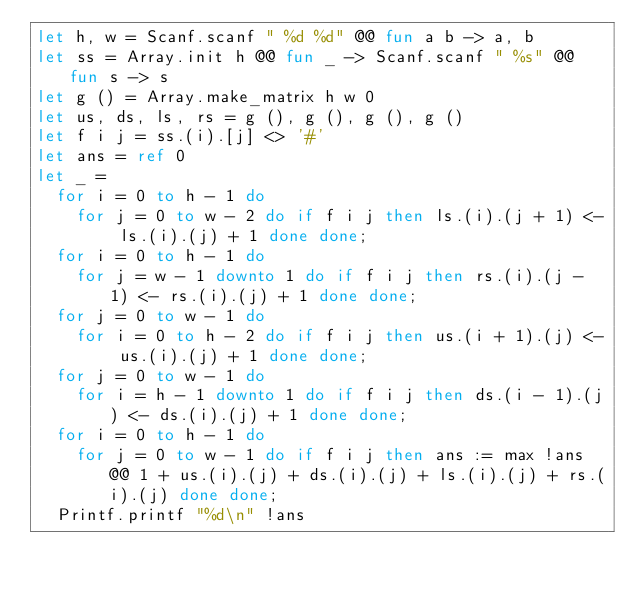<code> <loc_0><loc_0><loc_500><loc_500><_OCaml_>let h, w = Scanf.scanf " %d %d" @@ fun a b -> a, b
let ss = Array.init h @@ fun _ -> Scanf.scanf " %s" @@ fun s -> s
let g () = Array.make_matrix h w 0
let us, ds, ls, rs = g (), g (), g (), g ()
let f i j = ss.(i).[j] <> '#'
let ans = ref 0
let _ =
  for i = 0 to h - 1 do
    for j = 0 to w - 2 do if f i j then ls.(i).(j + 1) <- ls.(i).(j) + 1 done done;
  for i = 0 to h - 1 do
    for j = w - 1 downto 1 do if f i j then rs.(i).(j - 1) <- rs.(i).(j) + 1 done done;
  for j = 0 to w - 1 do
    for i = 0 to h - 2 do if f i j then us.(i + 1).(j) <- us.(i).(j) + 1 done done;
  for j = 0 to w - 1 do
    for i = h - 1 downto 1 do if f i j then ds.(i - 1).(j) <- ds.(i).(j) + 1 done done;
  for i = 0 to h - 1 do
    for j = 0 to w - 1 do if f i j then ans := max !ans @@ 1 + us.(i).(j) + ds.(i).(j) + ls.(i).(j) + rs.(i).(j) done done;
  Printf.printf "%d\n" !ans</code> 